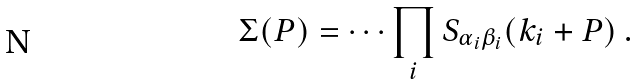Convert formula to latex. <formula><loc_0><loc_0><loc_500><loc_500>\Sigma ( P ) = \cdots \prod _ { i } S _ { \alpha _ { i } \beta _ { i } } ( k _ { i } + P ) \ .</formula> 